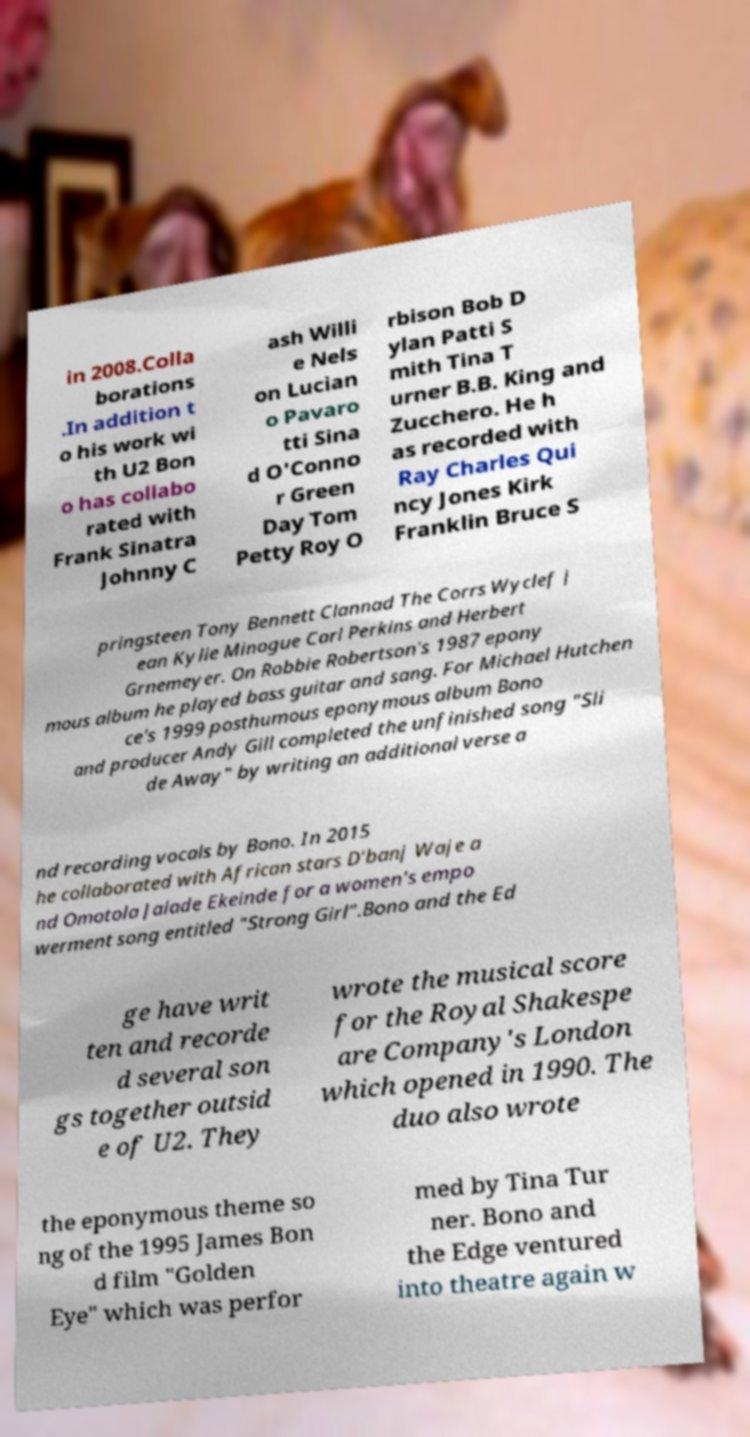There's text embedded in this image that I need extracted. Can you transcribe it verbatim? in 2008.Colla borations .In addition t o his work wi th U2 Bon o has collabo rated with Frank Sinatra Johnny C ash Willi e Nels on Lucian o Pavaro tti Sina d O'Conno r Green Day Tom Petty Roy O rbison Bob D ylan Patti S mith Tina T urner B.B. King and Zucchero. He h as recorded with Ray Charles Qui ncy Jones Kirk Franklin Bruce S pringsteen Tony Bennett Clannad The Corrs Wyclef J ean Kylie Minogue Carl Perkins and Herbert Grnemeyer. On Robbie Robertson's 1987 epony mous album he played bass guitar and sang. For Michael Hutchen ce's 1999 posthumous eponymous album Bono and producer Andy Gill completed the unfinished song "Sli de Away" by writing an additional verse a nd recording vocals by Bono. In 2015 he collaborated with African stars D'banj Waje a nd Omotola Jalade Ekeinde for a women's empo werment song entitled "Strong Girl".Bono and the Ed ge have writ ten and recorde d several son gs together outsid e of U2. They wrote the musical score for the Royal Shakespe are Company's London which opened in 1990. The duo also wrote the eponymous theme so ng of the 1995 James Bon d film "Golden Eye" which was perfor med by Tina Tur ner. Bono and the Edge ventured into theatre again w 